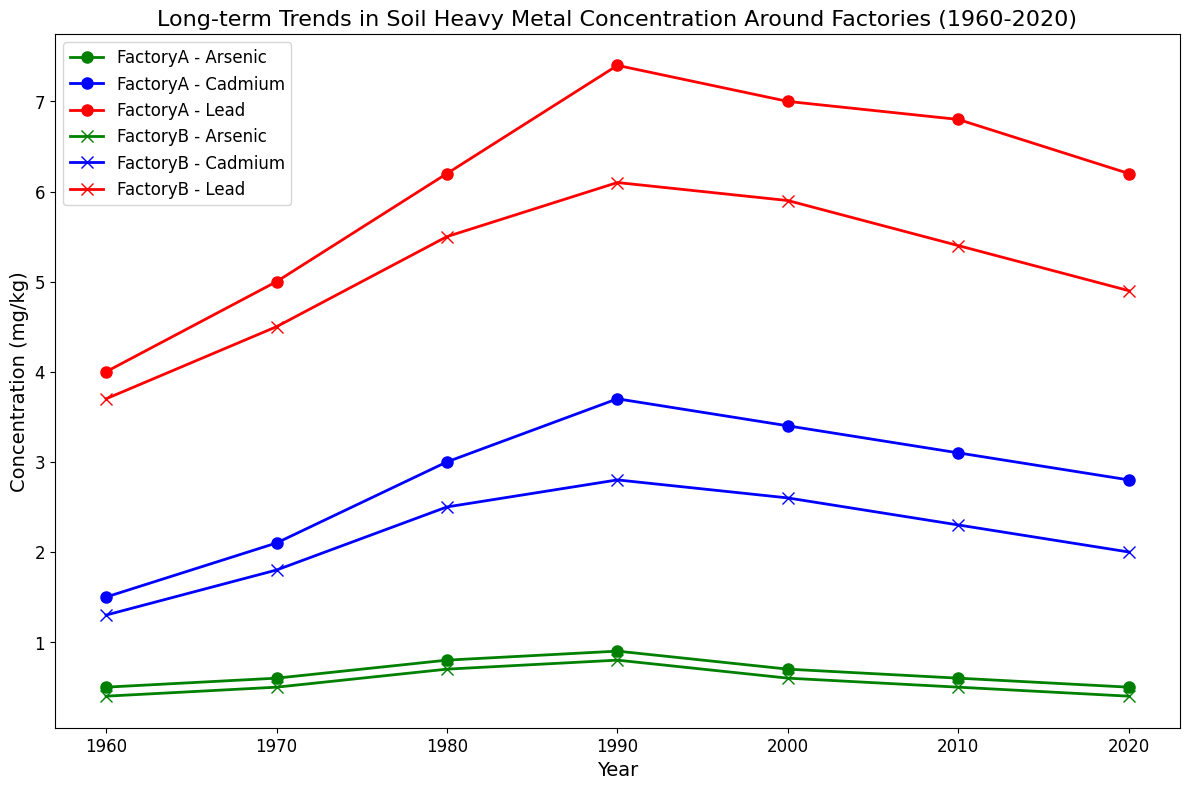What is the trend of Cadmium concentration in Factory A over the period 1960 to 2020? From the figure, trace the blue line with circle markers corresponding to Factory A and Cadmium across the years from 1960 to 2020. Observe the pattern.
Answer: It initially increases, peaks at 1990, then decreases What is the concentration difference of Arsenic in Factory B between 1960 and 2020? Refer to the green line with "x" markers. The concentration in 1960 is around 0.4 mg/kg and in 2020 it is also 0.4 mg/kg. Subtract the latter from the former.
Answer: 0 mg/kg Which heavy metal showed the highest concentration in 1990 around Factory B? Identify the lines representing data from Factory B in 1990. Compare the concentrations at this point for each metal.
Answer: Lead Compare the Lead concentrations between Factory A and Factory B in 1980. Which one is higher? Locate the red lines for both Factory A and Factory B in 1980. Observe the y-values for Lead.
Answer: Factory A How does the concentration of Cadmium in Factory B change from 1970 to 2000? Trace the blue line with "x" markers from 1970 to 2000. Note the values at these points and observe the change.
Answer: Increases from 1.8 to 2.6 mg/kg Which factory has a higher concentration of Arsenic in 2010? Refer to the green lines for both Factory A and Factory B at 2010 and compare their values.
Answer: Factory A How many years did it take for the Cadmium concentration in Factory A to peak, starting from 1960? Identify the peak concentration year for Cadmium in Factory A, which is 1990, and subtract 1960.
Answer: 30 years What is the average concentration of Lead in Factory B from 1960 to 2020? Sum the Lead concentration values for Factory B from each decade (3.7 + 4.5 + 5.5 + 6.1 + 5.9 + 5.4 + 4.9) and divide by the number of values (7).
Answer: (3.7 + 4.5 + 5.5 + 6.1 + 5.9 + 5.4 + 4.9) / 7 = 5.14 mg/kg Does Arsenic concentration in Factory A show an overall increasing or decreasing trend from 1960 to 2020? Look at the green line with circle markers, trace the trend from 1960 to 2020, and note the overall direction.
Answer: Decreasing 